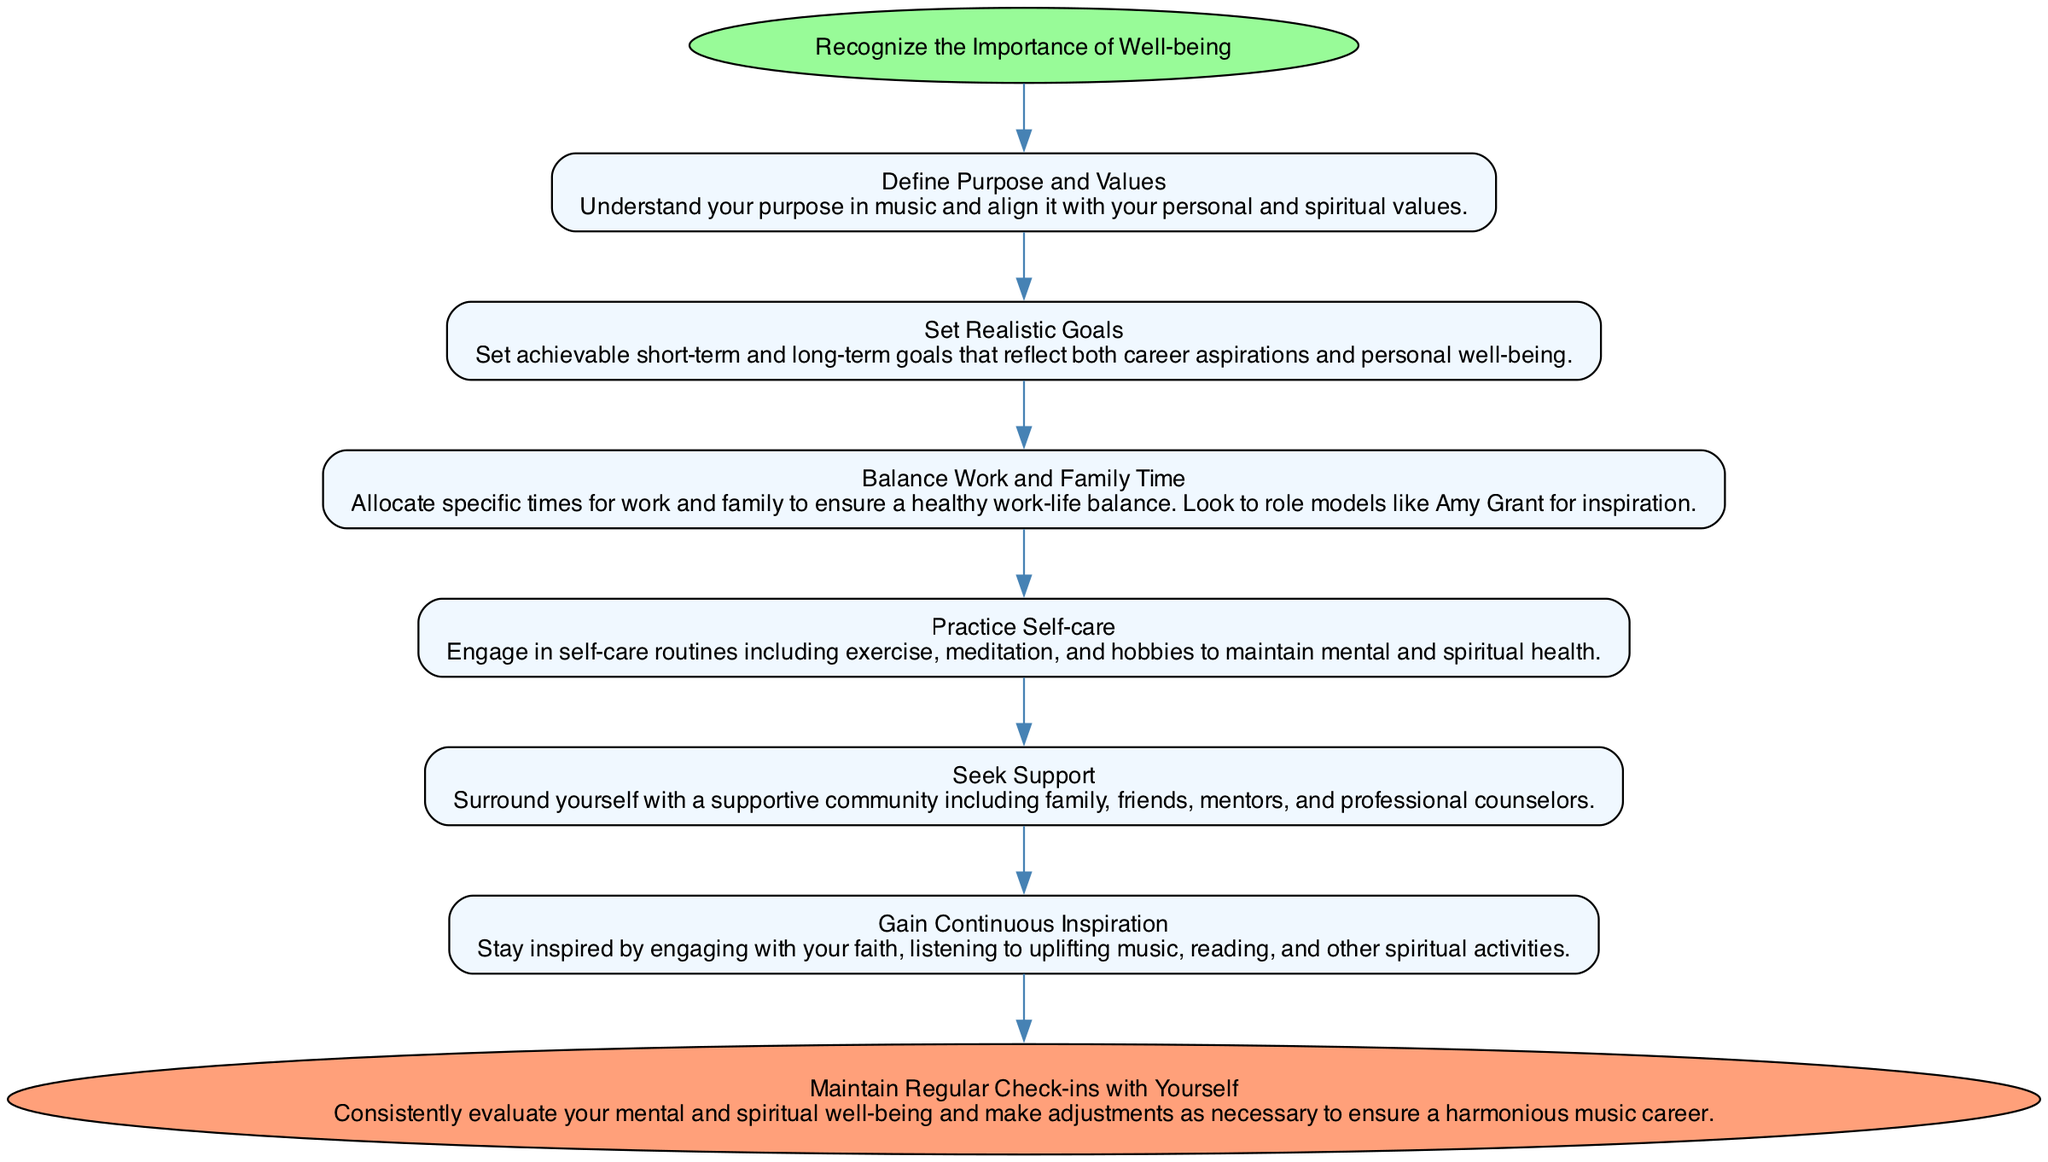What is the first step in maintaining well-being? The diagram starts with the node labeled "Recognize the Importance of Well-being." This is the first step that initiates the flow and sets the foundation for the subsequent actions.
Answer: Recognize the Importance of Well-being How many main elements are there in the diagram? The diagram contains six main elements listed under "elements" that represent individual steps in the process.
Answer: Six What is the next action after defining purpose and values? Following the node "Define Purpose and Values," the next action is shown as "Set Realistic Goals." This indicates the flow of steps taken to support well-being.
Answer: Set Realistic Goals What is the last step before reaching the end of the flow? The last node in the sequence before reaching the end is "Gain Continuous Inspiration." This represents the final preparatory action leading to the overall evaluation step.
Answer: Gain Continuous Inspiration What do you gain by seeking support? Seeking support involves "surrounding yourself with a supportive community including family, friends, mentors, and professional counselors," which aids in maintaining well-being and connection to others.
Answer: Supportive community How does balancing work and family time impact well-being? The diagram emphasizes "Balance Work and Family Time" as pivotal in ensuring a healthy work-life balance, thus contributing significantly to overall spiritual and mental well-being in a music career.
Answer: Healthy work-life balance What is the role of continuous inspiration in maintaining well-being? The node "Gain Continuous Inspiration" suggests the importance of staying inspired to maintain motivation and a positive mental state, which is essential for sustained well-being.
Answer: Maintain motivation What happens at the end of the flow chart? The flow chart concludes with "Maintain Regular Check-ins with Yourself," indicating the importance of self-evaluation and necessary adjustments for balance and health in one's career.
Answer: Maintain Regular Check-ins with Yourself 